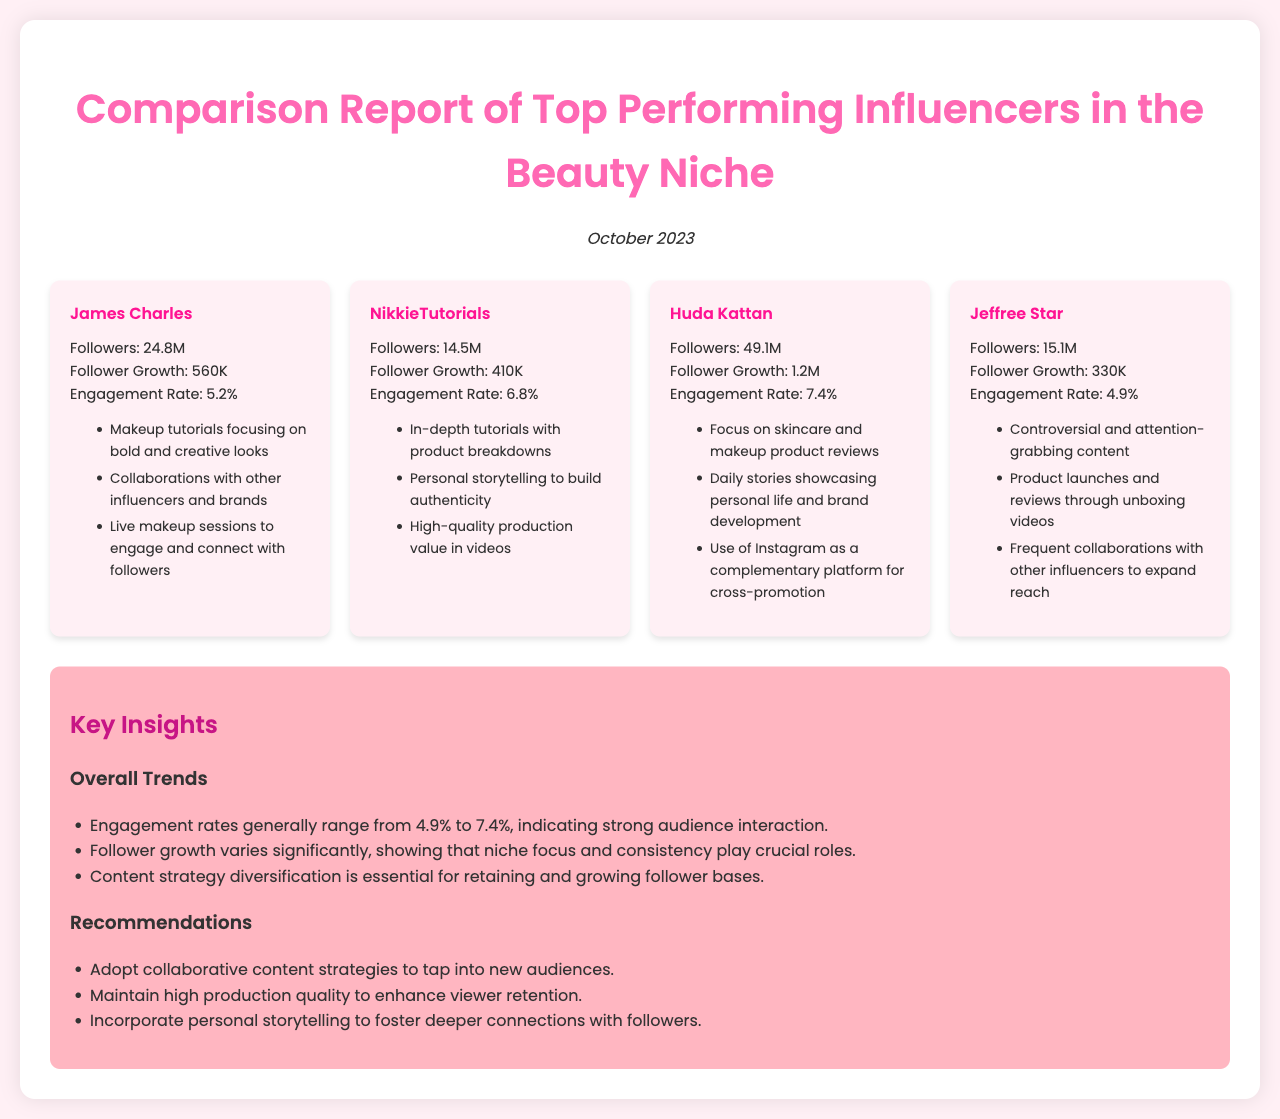What is the engagement rate of Huda Kattan? The engagement rate for Huda Kattan is displayed in the influencer card and is 7.4%.
Answer: 7.4% How many followers does NikkieTutorials have? The number of followers for NikkieTutorials is specified in the stats section and is 14.5M.
Answer: 14.5M Who has the highest follower growth? The highest follower growth can be found by comparing the growth numbers, and Huda Kattan has the highest at 1.2M.
Answer: Huda Kattan What content strategy is used by Jeffree Star? Jeffree Star's strategies are listed in the content strategy section, including "Controversial and attention-grabbing content."
Answer: Controversial and attention-grabbing content What are the key insights regarding engagement rates in the report? The insights note that engagement rates range between 4.9% and 7.4%, indicating strong audience interaction.
Answer: Strong audience interaction Which influencer focuses on skincare? By reviewing the content strategies, Huda Kattan is noted for focusing on skincare and makeup product reviews.
Answer: Huda Kattan What is the date of this report? The date is included in the introduction of the report, which specifies it as October 2023.
Answer: October 2023 What does the report recommend for content strategies? Recommendations in the document include adopting collaborative content strategies.
Answer: Adopt collaborative content strategies What is the total follower count of James Charles? James Charles's follower count is given in the stats section as 24.8M.
Answer: 24.8M 